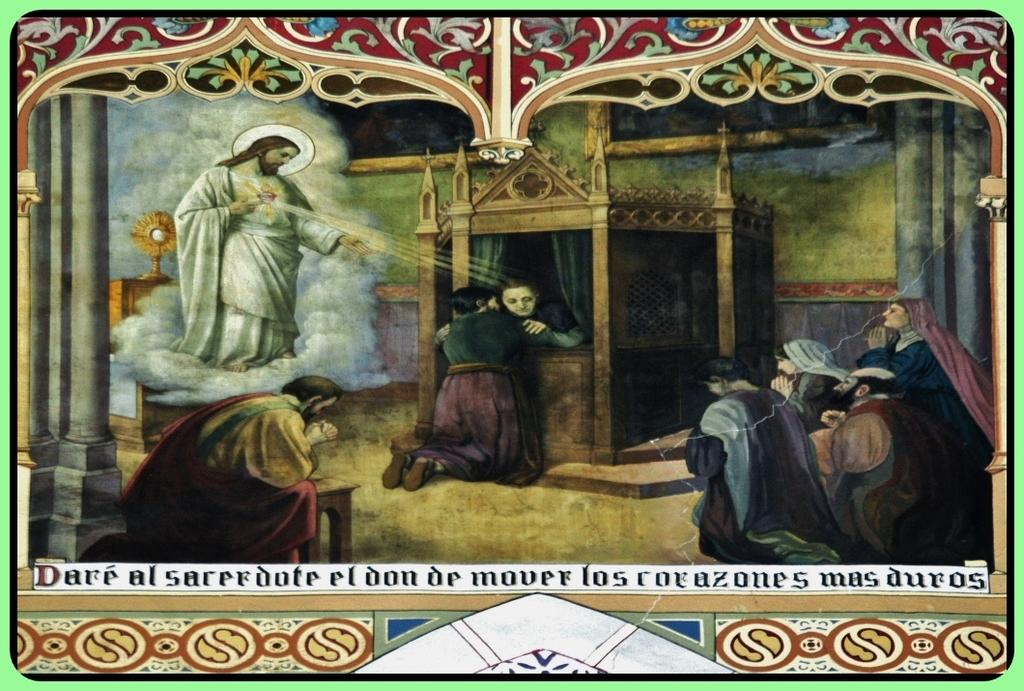What is the main subject of the poster in the image? The poster depicts some persons crouching down. Is there any religious figure on the poster? Yes, Jesus is present on the poster, showering blessings. What can be seen in the background of the image? There is a wall in the background of the image. Can you tell me how many times the ear is twisted in the image? There is no ear present in the image, nor is there any twisting action taking place. 